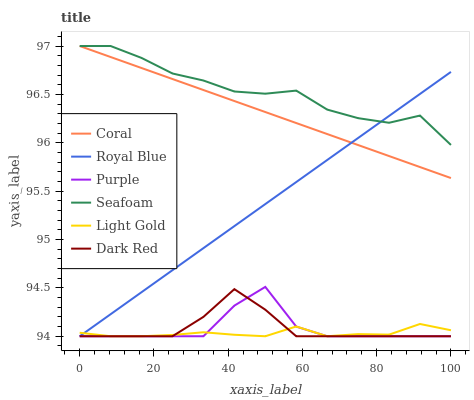Does Light Gold have the minimum area under the curve?
Answer yes or no. Yes. Does Seafoam have the maximum area under the curve?
Answer yes or no. Yes. Does Dark Red have the minimum area under the curve?
Answer yes or no. No. Does Dark Red have the maximum area under the curve?
Answer yes or no. No. Is Royal Blue the smoothest?
Answer yes or no. Yes. Is Purple the roughest?
Answer yes or no. Yes. Is Dark Red the smoothest?
Answer yes or no. No. Is Dark Red the roughest?
Answer yes or no. No. Does Coral have the lowest value?
Answer yes or no. No. Does Seafoam have the highest value?
Answer yes or no. Yes. Does Dark Red have the highest value?
Answer yes or no. No. Is Dark Red less than Seafoam?
Answer yes or no. Yes. Is Seafoam greater than Purple?
Answer yes or no. Yes. Does Royal Blue intersect Purple?
Answer yes or no. Yes. Is Royal Blue less than Purple?
Answer yes or no. No. Is Royal Blue greater than Purple?
Answer yes or no. No. Does Dark Red intersect Seafoam?
Answer yes or no. No. 